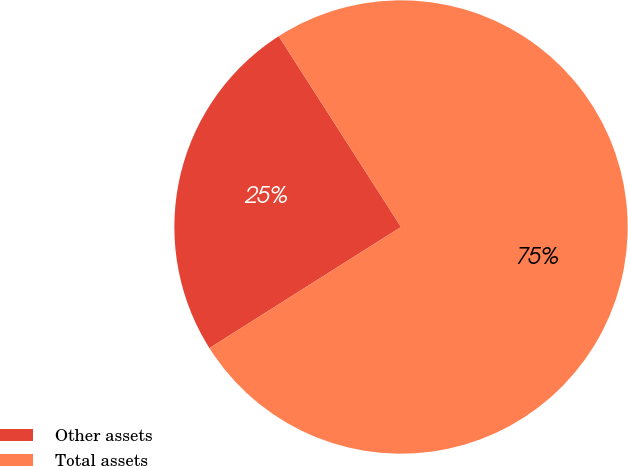Convert chart. <chart><loc_0><loc_0><loc_500><loc_500><pie_chart><fcel>Other assets<fcel>Total assets<nl><fcel>24.9%<fcel>75.1%<nl></chart> 